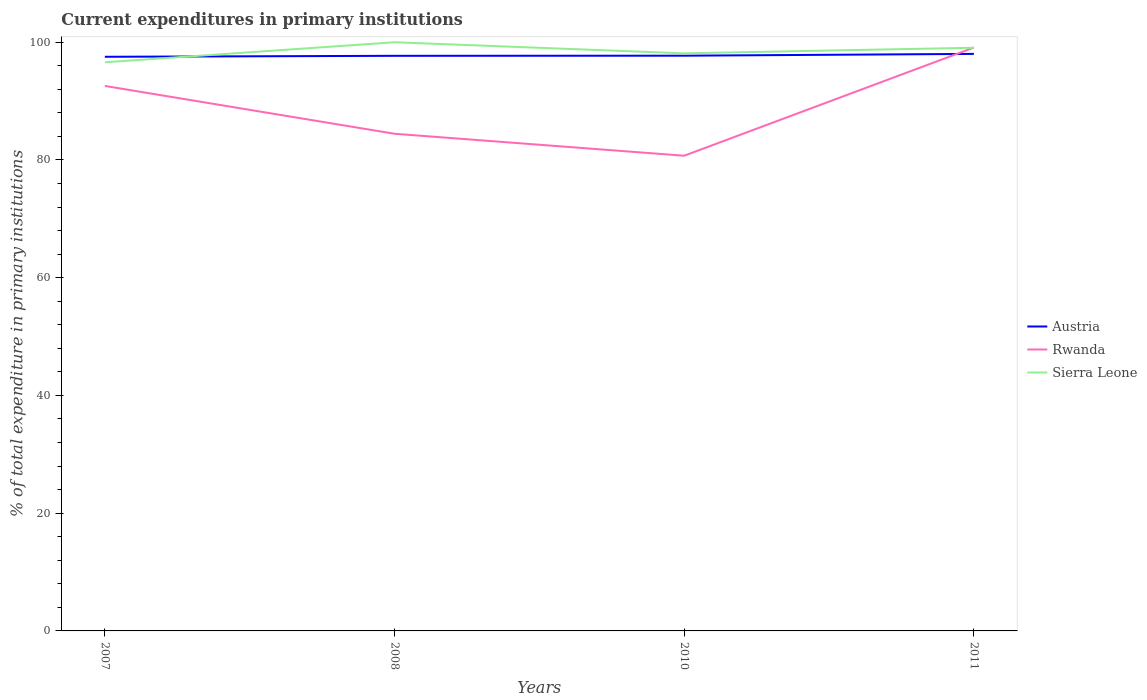How many different coloured lines are there?
Offer a very short reply. 3. Does the line corresponding to Sierra Leone intersect with the line corresponding to Rwanda?
Give a very brief answer. Yes. Is the number of lines equal to the number of legend labels?
Provide a short and direct response. Yes. Across all years, what is the maximum current expenditures in primary institutions in Austria?
Keep it short and to the point. 97.53. What is the total current expenditures in primary institutions in Sierra Leone in the graph?
Your answer should be compact. -3.4. What is the difference between the highest and the second highest current expenditures in primary institutions in Austria?
Offer a very short reply. 0.49. How many lines are there?
Offer a very short reply. 3. How many years are there in the graph?
Give a very brief answer. 4. What is the difference between two consecutive major ticks on the Y-axis?
Ensure brevity in your answer.  20. Are the values on the major ticks of Y-axis written in scientific E-notation?
Ensure brevity in your answer.  No. Does the graph contain grids?
Give a very brief answer. No. What is the title of the graph?
Your answer should be very brief. Current expenditures in primary institutions. What is the label or title of the X-axis?
Offer a terse response. Years. What is the label or title of the Y-axis?
Give a very brief answer. % of total expenditure in primary institutions. What is the % of total expenditure in primary institutions of Austria in 2007?
Keep it short and to the point. 97.53. What is the % of total expenditure in primary institutions of Rwanda in 2007?
Ensure brevity in your answer.  92.58. What is the % of total expenditure in primary institutions of Sierra Leone in 2007?
Provide a succinct answer. 96.6. What is the % of total expenditure in primary institutions of Austria in 2008?
Give a very brief answer. 97.7. What is the % of total expenditure in primary institutions of Rwanda in 2008?
Offer a very short reply. 84.46. What is the % of total expenditure in primary institutions in Sierra Leone in 2008?
Provide a succinct answer. 100. What is the % of total expenditure in primary institutions in Austria in 2010?
Your answer should be very brief. 97.72. What is the % of total expenditure in primary institutions of Rwanda in 2010?
Ensure brevity in your answer.  80.72. What is the % of total expenditure in primary institutions of Sierra Leone in 2010?
Give a very brief answer. 98.12. What is the % of total expenditure in primary institutions of Austria in 2011?
Ensure brevity in your answer.  98.02. What is the % of total expenditure in primary institutions of Rwanda in 2011?
Provide a succinct answer. 99.1. What is the % of total expenditure in primary institutions of Sierra Leone in 2011?
Ensure brevity in your answer.  99.07. Across all years, what is the maximum % of total expenditure in primary institutions in Austria?
Offer a terse response. 98.02. Across all years, what is the maximum % of total expenditure in primary institutions in Rwanda?
Give a very brief answer. 99.1. Across all years, what is the minimum % of total expenditure in primary institutions of Austria?
Make the answer very short. 97.53. Across all years, what is the minimum % of total expenditure in primary institutions of Rwanda?
Ensure brevity in your answer.  80.72. Across all years, what is the minimum % of total expenditure in primary institutions of Sierra Leone?
Your response must be concise. 96.6. What is the total % of total expenditure in primary institutions in Austria in the graph?
Ensure brevity in your answer.  390.96. What is the total % of total expenditure in primary institutions in Rwanda in the graph?
Your answer should be very brief. 356.86. What is the total % of total expenditure in primary institutions in Sierra Leone in the graph?
Offer a very short reply. 393.78. What is the difference between the % of total expenditure in primary institutions of Austria in 2007 and that in 2008?
Offer a very short reply. -0.17. What is the difference between the % of total expenditure in primary institutions in Rwanda in 2007 and that in 2008?
Provide a short and direct response. 8.12. What is the difference between the % of total expenditure in primary institutions of Sierra Leone in 2007 and that in 2008?
Ensure brevity in your answer.  -3.4. What is the difference between the % of total expenditure in primary institutions of Austria in 2007 and that in 2010?
Provide a succinct answer. -0.19. What is the difference between the % of total expenditure in primary institutions in Rwanda in 2007 and that in 2010?
Your answer should be very brief. 11.86. What is the difference between the % of total expenditure in primary institutions of Sierra Leone in 2007 and that in 2010?
Your response must be concise. -1.52. What is the difference between the % of total expenditure in primary institutions in Austria in 2007 and that in 2011?
Offer a terse response. -0.49. What is the difference between the % of total expenditure in primary institutions in Rwanda in 2007 and that in 2011?
Offer a very short reply. -6.52. What is the difference between the % of total expenditure in primary institutions in Sierra Leone in 2007 and that in 2011?
Offer a very short reply. -2.47. What is the difference between the % of total expenditure in primary institutions of Austria in 2008 and that in 2010?
Your answer should be compact. -0.02. What is the difference between the % of total expenditure in primary institutions in Rwanda in 2008 and that in 2010?
Your answer should be very brief. 3.73. What is the difference between the % of total expenditure in primary institutions of Sierra Leone in 2008 and that in 2010?
Provide a short and direct response. 1.88. What is the difference between the % of total expenditure in primary institutions of Austria in 2008 and that in 2011?
Ensure brevity in your answer.  -0.33. What is the difference between the % of total expenditure in primary institutions in Rwanda in 2008 and that in 2011?
Offer a very short reply. -14.64. What is the difference between the % of total expenditure in primary institutions in Sierra Leone in 2008 and that in 2011?
Provide a short and direct response. 0.93. What is the difference between the % of total expenditure in primary institutions in Austria in 2010 and that in 2011?
Your answer should be very brief. -0.3. What is the difference between the % of total expenditure in primary institutions in Rwanda in 2010 and that in 2011?
Offer a terse response. -18.38. What is the difference between the % of total expenditure in primary institutions of Sierra Leone in 2010 and that in 2011?
Ensure brevity in your answer.  -0.95. What is the difference between the % of total expenditure in primary institutions of Austria in 2007 and the % of total expenditure in primary institutions of Rwanda in 2008?
Make the answer very short. 13.07. What is the difference between the % of total expenditure in primary institutions of Austria in 2007 and the % of total expenditure in primary institutions of Sierra Leone in 2008?
Your response must be concise. -2.47. What is the difference between the % of total expenditure in primary institutions of Rwanda in 2007 and the % of total expenditure in primary institutions of Sierra Leone in 2008?
Make the answer very short. -7.42. What is the difference between the % of total expenditure in primary institutions of Austria in 2007 and the % of total expenditure in primary institutions of Rwanda in 2010?
Offer a very short reply. 16.81. What is the difference between the % of total expenditure in primary institutions of Austria in 2007 and the % of total expenditure in primary institutions of Sierra Leone in 2010?
Your answer should be very brief. -0.58. What is the difference between the % of total expenditure in primary institutions of Rwanda in 2007 and the % of total expenditure in primary institutions of Sierra Leone in 2010?
Ensure brevity in your answer.  -5.54. What is the difference between the % of total expenditure in primary institutions of Austria in 2007 and the % of total expenditure in primary institutions of Rwanda in 2011?
Provide a short and direct response. -1.57. What is the difference between the % of total expenditure in primary institutions of Austria in 2007 and the % of total expenditure in primary institutions of Sierra Leone in 2011?
Provide a short and direct response. -1.54. What is the difference between the % of total expenditure in primary institutions in Rwanda in 2007 and the % of total expenditure in primary institutions in Sierra Leone in 2011?
Give a very brief answer. -6.49. What is the difference between the % of total expenditure in primary institutions of Austria in 2008 and the % of total expenditure in primary institutions of Rwanda in 2010?
Provide a short and direct response. 16.97. What is the difference between the % of total expenditure in primary institutions in Austria in 2008 and the % of total expenditure in primary institutions in Sierra Leone in 2010?
Give a very brief answer. -0.42. What is the difference between the % of total expenditure in primary institutions in Rwanda in 2008 and the % of total expenditure in primary institutions in Sierra Leone in 2010?
Your answer should be very brief. -13.66. What is the difference between the % of total expenditure in primary institutions in Austria in 2008 and the % of total expenditure in primary institutions in Rwanda in 2011?
Provide a succinct answer. -1.4. What is the difference between the % of total expenditure in primary institutions in Austria in 2008 and the % of total expenditure in primary institutions in Sierra Leone in 2011?
Offer a very short reply. -1.37. What is the difference between the % of total expenditure in primary institutions in Rwanda in 2008 and the % of total expenditure in primary institutions in Sierra Leone in 2011?
Offer a terse response. -14.61. What is the difference between the % of total expenditure in primary institutions in Austria in 2010 and the % of total expenditure in primary institutions in Rwanda in 2011?
Offer a very short reply. -1.38. What is the difference between the % of total expenditure in primary institutions of Austria in 2010 and the % of total expenditure in primary institutions of Sierra Leone in 2011?
Keep it short and to the point. -1.35. What is the difference between the % of total expenditure in primary institutions of Rwanda in 2010 and the % of total expenditure in primary institutions of Sierra Leone in 2011?
Your answer should be compact. -18.34. What is the average % of total expenditure in primary institutions in Austria per year?
Keep it short and to the point. 97.74. What is the average % of total expenditure in primary institutions in Rwanda per year?
Offer a terse response. 89.21. What is the average % of total expenditure in primary institutions of Sierra Leone per year?
Ensure brevity in your answer.  98.44. In the year 2007, what is the difference between the % of total expenditure in primary institutions of Austria and % of total expenditure in primary institutions of Rwanda?
Provide a succinct answer. 4.95. In the year 2007, what is the difference between the % of total expenditure in primary institutions of Austria and % of total expenditure in primary institutions of Sierra Leone?
Ensure brevity in your answer.  0.93. In the year 2007, what is the difference between the % of total expenditure in primary institutions in Rwanda and % of total expenditure in primary institutions in Sierra Leone?
Provide a succinct answer. -4.02. In the year 2008, what is the difference between the % of total expenditure in primary institutions of Austria and % of total expenditure in primary institutions of Rwanda?
Your response must be concise. 13.24. In the year 2008, what is the difference between the % of total expenditure in primary institutions of Austria and % of total expenditure in primary institutions of Sierra Leone?
Offer a very short reply. -2.3. In the year 2008, what is the difference between the % of total expenditure in primary institutions in Rwanda and % of total expenditure in primary institutions in Sierra Leone?
Provide a succinct answer. -15.54. In the year 2010, what is the difference between the % of total expenditure in primary institutions of Austria and % of total expenditure in primary institutions of Rwanda?
Keep it short and to the point. 16.99. In the year 2010, what is the difference between the % of total expenditure in primary institutions in Austria and % of total expenditure in primary institutions in Sierra Leone?
Your answer should be compact. -0.4. In the year 2010, what is the difference between the % of total expenditure in primary institutions of Rwanda and % of total expenditure in primary institutions of Sierra Leone?
Keep it short and to the point. -17.39. In the year 2011, what is the difference between the % of total expenditure in primary institutions in Austria and % of total expenditure in primary institutions in Rwanda?
Your answer should be compact. -1.08. In the year 2011, what is the difference between the % of total expenditure in primary institutions in Austria and % of total expenditure in primary institutions in Sierra Leone?
Offer a terse response. -1.04. In the year 2011, what is the difference between the % of total expenditure in primary institutions in Rwanda and % of total expenditure in primary institutions in Sierra Leone?
Your answer should be very brief. 0.03. What is the ratio of the % of total expenditure in primary institutions of Austria in 2007 to that in 2008?
Your answer should be compact. 1. What is the ratio of the % of total expenditure in primary institutions of Rwanda in 2007 to that in 2008?
Provide a short and direct response. 1.1. What is the ratio of the % of total expenditure in primary institutions in Rwanda in 2007 to that in 2010?
Make the answer very short. 1.15. What is the ratio of the % of total expenditure in primary institutions of Sierra Leone in 2007 to that in 2010?
Offer a terse response. 0.98. What is the ratio of the % of total expenditure in primary institutions of Austria in 2007 to that in 2011?
Your answer should be compact. 0.99. What is the ratio of the % of total expenditure in primary institutions in Rwanda in 2007 to that in 2011?
Keep it short and to the point. 0.93. What is the ratio of the % of total expenditure in primary institutions of Sierra Leone in 2007 to that in 2011?
Provide a succinct answer. 0.98. What is the ratio of the % of total expenditure in primary institutions of Austria in 2008 to that in 2010?
Offer a terse response. 1. What is the ratio of the % of total expenditure in primary institutions of Rwanda in 2008 to that in 2010?
Offer a terse response. 1.05. What is the ratio of the % of total expenditure in primary institutions of Sierra Leone in 2008 to that in 2010?
Ensure brevity in your answer.  1.02. What is the ratio of the % of total expenditure in primary institutions of Austria in 2008 to that in 2011?
Your response must be concise. 1. What is the ratio of the % of total expenditure in primary institutions of Rwanda in 2008 to that in 2011?
Give a very brief answer. 0.85. What is the ratio of the % of total expenditure in primary institutions in Sierra Leone in 2008 to that in 2011?
Offer a terse response. 1.01. What is the ratio of the % of total expenditure in primary institutions of Austria in 2010 to that in 2011?
Your response must be concise. 1. What is the ratio of the % of total expenditure in primary institutions of Rwanda in 2010 to that in 2011?
Your answer should be very brief. 0.81. What is the difference between the highest and the second highest % of total expenditure in primary institutions in Austria?
Your answer should be compact. 0.3. What is the difference between the highest and the second highest % of total expenditure in primary institutions of Rwanda?
Keep it short and to the point. 6.52. What is the difference between the highest and the second highest % of total expenditure in primary institutions in Sierra Leone?
Provide a succinct answer. 0.93. What is the difference between the highest and the lowest % of total expenditure in primary institutions in Austria?
Keep it short and to the point. 0.49. What is the difference between the highest and the lowest % of total expenditure in primary institutions in Rwanda?
Provide a short and direct response. 18.38. What is the difference between the highest and the lowest % of total expenditure in primary institutions of Sierra Leone?
Offer a very short reply. 3.4. 